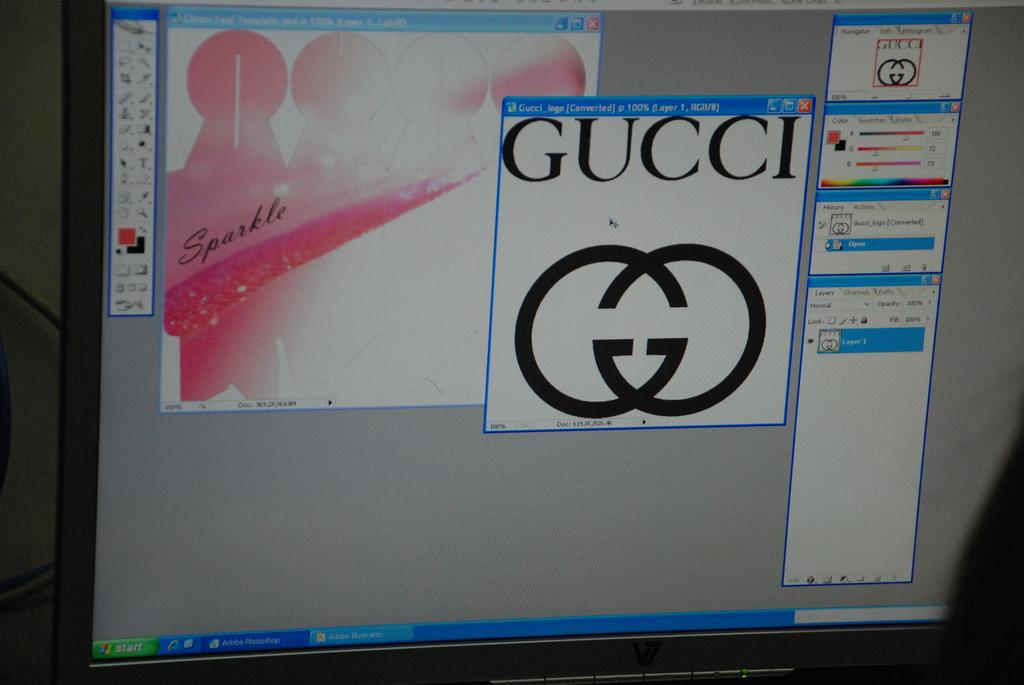<image>
Write a terse but informative summary of the picture. a computer screen with a tab open to a gucci drawing 